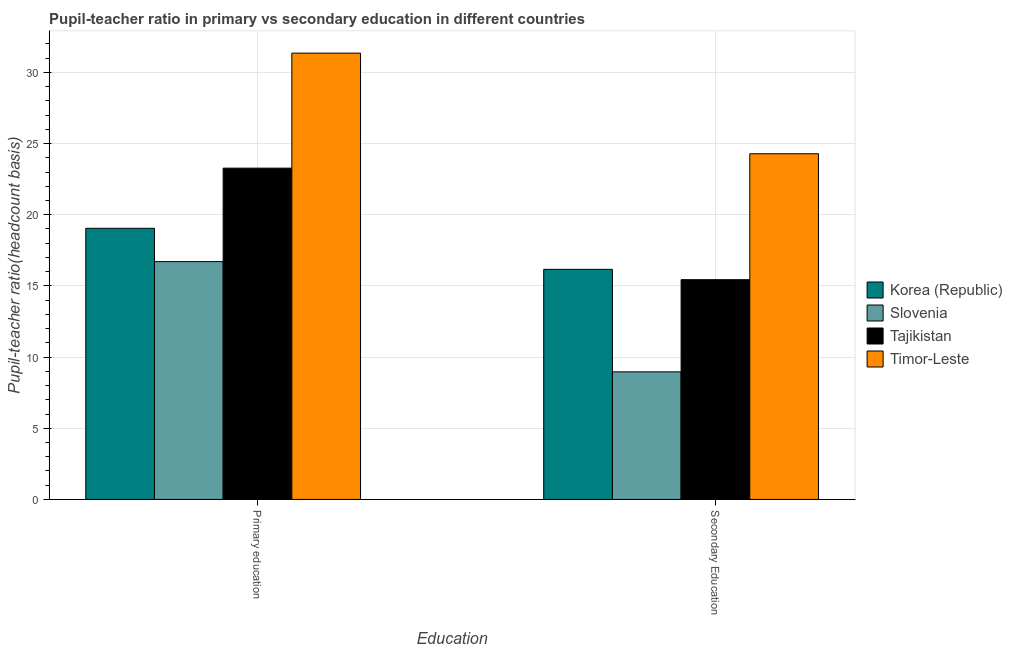How many groups of bars are there?
Provide a succinct answer. 2. Are the number of bars on each tick of the X-axis equal?
Make the answer very short. Yes. How many bars are there on the 2nd tick from the left?
Provide a succinct answer. 4. What is the pupil-teacher ratio in primary education in Tajikistan?
Keep it short and to the point. 23.27. Across all countries, what is the maximum pupil teacher ratio on secondary education?
Give a very brief answer. 24.29. Across all countries, what is the minimum pupil-teacher ratio in primary education?
Give a very brief answer. 16.71. In which country was the pupil teacher ratio on secondary education maximum?
Offer a terse response. Timor-Leste. In which country was the pupil teacher ratio on secondary education minimum?
Keep it short and to the point. Slovenia. What is the total pupil teacher ratio on secondary education in the graph?
Ensure brevity in your answer.  64.85. What is the difference between the pupil teacher ratio on secondary education in Slovenia and that in Timor-Leste?
Keep it short and to the point. -15.32. What is the difference between the pupil-teacher ratio in primary education in Tajikistan and the pupil teacher ratio on secondary education in Korea (Republic)?
Offer a very short reply. 7.11. What is the average pupil-teacher ratio in primary education per country?
Offer a very short reply. 22.6. What is the difference between the pupil-teacher ratio in primary education and pupil teacher ratio on secondary education in Slovenia?
Provide a succinct answer. 7.75. What is the ratio of the pupil-teacher ratio in primary education in Slovenia to that in Korea (Republic)?
Ensure brevity in your answer.  0.88. In how many countries, is the pupil-teacher ratio in primary education greater than the average pupil-teacher ratio in primary education taken over all countries?
Your response must be concise. 2. What does the 2nd bar from the left in Primary education represents?
Make the answer very short. Slovenia. What does the 3rd bar from the right in Secondary Education represents?
Give a very brief answer. Slovenia. How many bars are there?
Your answer should be compact. 8. Are all the bars in the graph horizontal?
Provide a short and direct response. No. What is the difference between two consecutive major ticks on the Y-axis?
Provide a succinct answer. 5. Does the graph contain any zero values?
Provide a succinct answer. No. Does the graph contain grids?
Make the answer very short. Yes. How many legend labels are there?
Give a very brief answer. 4. How are the legend labels stacked?
Offer a terse response. Vertical. What is the title of the graph?
Your response must be concise. Pupil-teacher ratio in primary vs secondary education in different countries. Does "Moldova" appear as one of the legend labels in the graph?
Your answer should be very brief. No. What is the label or title of the X-axis?
Offer a very short reply. Education. What is the label or title of the Y-axis?
Keep it short and to the point. Pupil-teacher ratio(headcount basis). What is the Pupil-teacher ratio(headcount basis) in Korea (Republic) in Primary education?
Your answer should be compact. 19.05. What is the Pupil-teacher ratio(headcount basis) of Slovenia in Primary education?
Make the answer very short. 16.71. What is the Pupil-teacher ratio(headcount basis) of Tajikistan in Primary education?
Your answer should be compact. 23.27. What is the Pupil-teacher ratio(headcount basis) in Timor-Leste in Primary education?
Make the answer very short. 31.35. What is the Pupil-teacher ratio(headcount basis) in Korea (Republic) in Secondary Education?
Provide a short and direct response. 16.16. What is the Pupil-teacher ratio(headcount basis) of Slovenia in Secondary Education?
Your answer should be compact. 8.96. What is the Pupil-teacher ratio(headcount basis) in Tajikistan in Secondary Education?
Provide a succinct answer. 15.44. What is the Pupil-teacher ratio(headcount basis) in Timor-Leste in Secondary Education?
Provide a short and direct response. 24.29. Across all Education, what is the maximum Pupil-teacher ratio(headcount basis) of Korea (Republic)?
Keep it short and to the point. 19.05. Across all Education, what is the maximum Pupil-teacher ratio(headcount basis) in Slovenia?
Provide a short and direct response. 16.71. Across all Education, what is the maximum Pupil-teacher ratio(headcount basis) in Tajikistan?
Your answer should be compact. 23.27. Across all Education, what is the maximum Pupil-teacher ratio(headcount basis) of Timor-Leste?
Offer a terse response. 31.35. Across all Education, what is the minimum Pupil-teacher ratio(headcount basis) of Korea (Republic)?
Your answer should be compact. 16.16. Across all Education, what is the minimum Pupil-teacher ratio(headcount basis) of Slovenia?
Provide a succinct answer. 8.96. Across all Education, what is the minimum Pupil-teacher ratio(headcount basis) in Tajikistan?
Your answer should be compact. 15.44. Across all Education, what is the minimum Pupil-teacher ratio(headcount basis) of Timor-Leste?
Offer a very short reply. 24.29. What is the total Pupil-teacher ratio(headcount basis) of Korea (Republic) in the graph?
Your response must be concise. 35.21. What is the total Pupil-teacher ratio(headcount basis) in Slovenia in the graph?
Give a very brief answer. 25.67. What is the total Pupil-teacher ratio(headcount basis) in Tajikistan in the graph?
Give a very brief answer. 38.71. What is the total Pupil-teacher ratio(headcount basis) of Timor-Leste in the graph?
Make the answer very short. 55.64. What is the difference between the Pupil-teacher ratio(headcount basis) in Korea (Republic) in Primary education and that in Secondary Education?
Ensure brevity in your answer.  2.88. What is the difference between the Pupil-teacher ratio(headcount basis) in Slovenia in Primary education and that in Secondary Education?
Keep it short and to the point. 7.75. What is the difference between the Pupil-teacher ratio(headcount basis) of Tajikistan in Primary education and that in Secondary Education?
Give a very brief answer. 7.84. What is the difference between the Pupil-teacher ratio(headcount basis) in Timor-Leste in Primary education and that in Secondary Education?
Make the answer very short. 7.07. What is the difference between the Pupil-teacher ratio(headcount basis) of Korea (Republic) in Primary education and the Pupil-teacher ratio(headcount basis) of Slovenia in Secondary Education?
Offer a very short reply. 10.09. What is the difference between the Pupil-teacher ratio(headcount basis) in Korea (Republic) in Primary education and the Pupil-teacher ratio(headcount basis) in Tajikistan in Secondary Education?
Keep it short and to the point. 3.61. What is the difference between the Pupil-teacher ratio(headcount basis) in Korea (Republic) in Primary education and the Pupil-teacher ratio(headcount basis) in Timor-Leste in Secondary Education?
Your response must be concise. -5.24. What is the difference between the Pupil-teacher ratio(headcount basis) of Slovenia in Primary education and the Pupil-teacher ratio(headcount basis) of Tajikistan in Secondary Education?
Your answer should be compact. 1.27. What is the difference between the Pupil-teacher ratio(headcount basis) of Slovenia in Primary education and the Pupil-teacher ratio(headcount basis) of Timor-Leste in Secondary Education?
Make the answer very short. -7.58. What is the difference between the Pupil-teacher ratio(headcount basis) of Tajikistan in Primary education and the Pupil-teacher ratio(headcount basis) of Timor-Leste in Secondary Education?
Your response must be concise. -1.01. What is the average Pupil-teacher ratio(headcount basis) of Korea (Republic) per Education?
Your response must be concise. 17.61. What is the average Pupil-teacher ratio(headcount basis) in Slovenia per Education?
Keep it short and to the point. 12.84. What is the average Pupil-teacher ratio(headcount basis) in Tajikistan per Education?
Your answer should be very brief. 19.36. What is the average Pupil-teacher ratio(headcount basis) in Timor-Leste per Education?
Make the answer very short. 27.82. What is the difference between the Pupil-teacher ratio(headcount basis) of Korea (Republic) and Pupil-teacher ratio(headcount basis) of Slovenia in Primary education?
Make the answer very short. 2.34. What is the difference between the Pupil-teacher ratio(headcount basis) in Korea (Republic) and Pupil-teacher ratio(headcount basis) in Tajikistan in Primary education?
Provide a short and direct response. -4.23. What is the difference between the Pupil-teacher ratio(headcount basis) of Korea (Republic) and Pupil-teacher ratio(headcount basis) of Timor-Leste in Primary education?
Keep it short and to the point. -12.31. What is the difference between the Pupil-teacher ratio(headcount basis) in Slovenia and Pupil-teacher ratio(headcount basis) in Tajikistan in Primary education?
Ensure brevity in your answer.  -6.57. What is the difference between the Pupil-teacher ratio(headcount basis) in Slovenia and Pupil-teacher ratio(headcount basis) in Timor-Leste in Primary education?
Offer a very short reply. -14.65. What is the difference between the Pupil-teacher ratio(headcount basis) of Tajikistan and Pupil-teacher ratio(headcount basis) of Timor-Leste in Primary education?
Your answer should be very brief. -8.08. What is the difference between the Pupil-teacher ratio(headcount basis) in Korea (Republic) and Pupil-teacher ratio(headcount basis) in Slovenia in Secondary Education?
Provide a short and direct response. 7.2. What is the difference between the Pupil-teacher ratio(headcount basis) of Korea (Republic) and Pupil-teacher ratio(headcount basis) of Tajikistan in Secondary Education?
Ensure brevity in your answer.  0.73. What is the difference between the Pupil-teacher ratio(headcount basis) of Korea (Republic) and Pupil-teacher ratio(headcount basis) of Timor-Leste in Secondary Education?
Your answer should be very brief. -8.12. What is the difference between the Pupil-teacher ratio(headcount basis) in Slovenia and Pupil-teacher ratio(headcount basis) in Tajikistan in Secondary Education?
Offer a very short reply. -6.48. What is the difference between the Pupil-teacher ratio(headcount basis) in Slovenia and Pupil-teacher ratio(headcount basis) in Timor-Leste in Secondary Education?
Your answer should be very brief. -15.32. What is the difference between the Pupil-teacher ratio(headcount basis) of Tajikistan and Pupil-teacher ratio(headcount basis) of Timor-Leste in Secondary Education?
Your response must be concise. -8.85. What is the ratio of the Pupil-teacher ratio(headcount basis) in Korea (Republic) in Primary education to that in Secondary Education?
Provide a short and direct response. 1.18. What is the ratio of the Pupil-teacher ratio(headcount basis) in Slovenia in Primary education to that in Secondary Education?
Ensure brevity in your answer.  1.86. What is the ratio of the Pupil-teacher ratio(headcount basis) in Tajikistan in Primary education to that in Secondary Education?
Make the answer very short. 1.51. What is the ratio of the Pupil-teacher ratio(headcount basis) of Timor-Leste in Primary education to that in Secondary Education?
Offer a terse response. 1.29. What is the difference between the highest and the second highest Pupil-teacher ratio(headcount basis) in Korea (Republic)?
Ensure brevity in your answer.  2.88. What is the difference between the highest and the second highest Pupil-teacher ratio(headcount basis) of Slovenia?
Your response must be concise. 7.75. What is the difference between the highest and the second highest Pupil-teacher ratio(headcount basis) in Tajikistan?
Offer a terse response. 7.84. What is the difference between the highest and the second highest Pupil-teacher ratio(headcount basis) of Timor-Leste?
Your response must be concise. 7.07. What is the difference between the highest and the lowest Pupil-teacher ratio(headcount basis) in Korea (Republic)?
Your answer should be very brief. 2.88. What is the difference between the highest and the lowest Pupil-teacher ratio(headcount basis) of Slovenia?
Give a very brief answer. 7.75. What is the difference between the highest and the lowest Pupil-teacher ratio(headcount basis) of Tajikistan?
Your response must be concise. 7.84. What is the difference between the highest and the lowest Pupil-teacher ratio(headcount basis) in Timor-Leste?
Offer a very short reply. 7.07. 